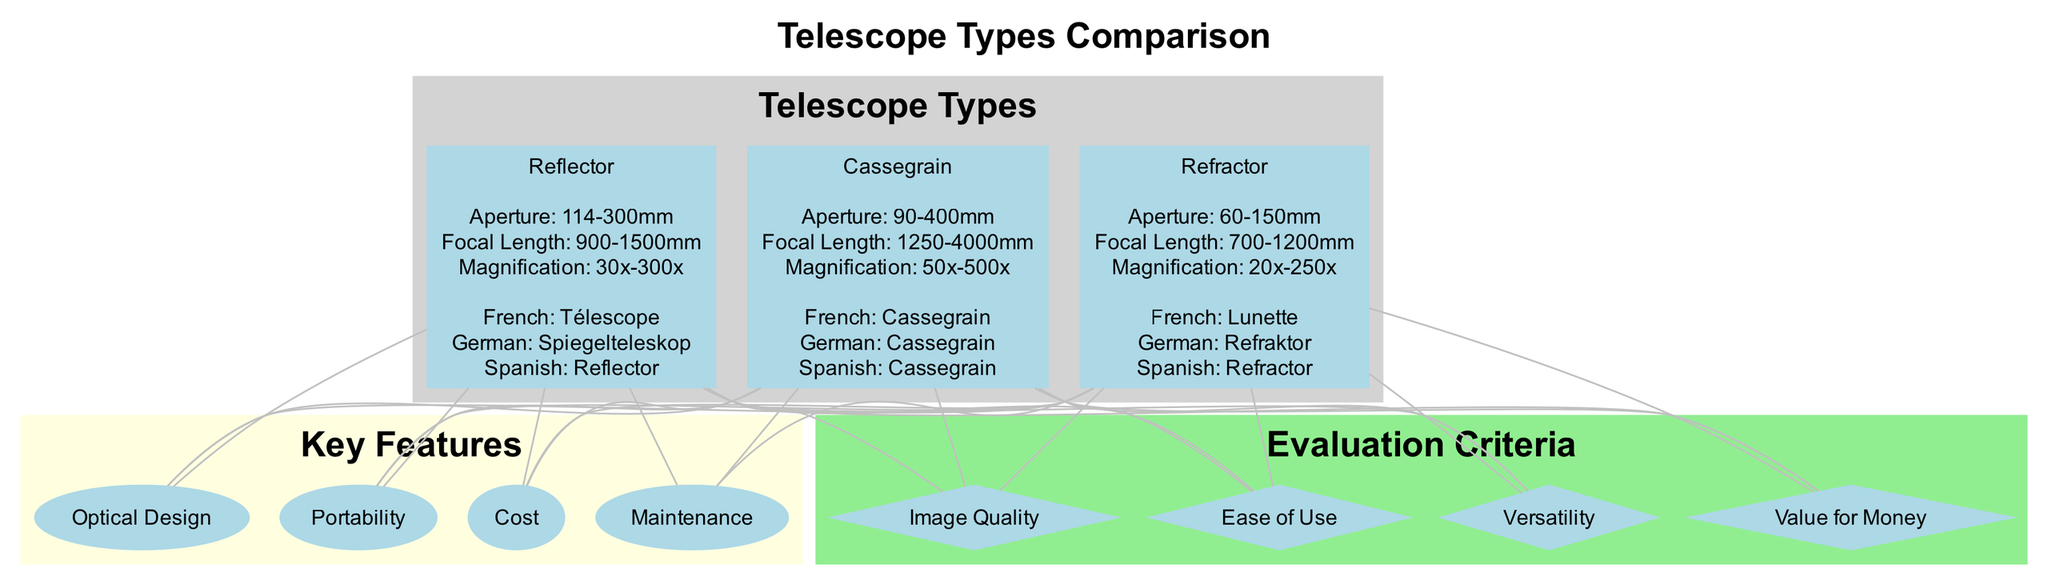What is the aperture range of the Refractor telescope? The "Refractor" telescope in the diagram lists the aperture range as "60-150mm". This information can be found in the specifications section corresponding to the "Refractor" node.
Answer: 60-150mm How many key features are listed in the diagram? The diagram includes a subgraph labeled "Key Features", which contains four features: "Optical Design," "Portability," "Cost," and "Maintenance." Counting these gives a total of four key features.
Answer: 4 What is the maximum magnification of the Cassegrain telescope? In the "Cassegrain" node, the specifications list the maximum magnification as "500x." This is the highest value indicated under the magnification specification for that particular telescope type.
Answer: 500x Which telescope type has the largest aperture range? Comparing the aperture ranges: "Refractor" (60-150mm), "Reflector" (114-300mm), and "Cassegrain" (90-400mm), the "Cassegrain" has the largest aperture range (90-400mm). Therefore, the reasoning involves evaluating the stated ranges to compare them accurately.
Answer: Cassegrain What is the localized term for Reflector in German? In the diagram, the "Reflector" telescope node provides a localized term for German as "Spiegelteleskop." This information is found under the localized terms section associated with the "Reflector" telescope.
Answer: Spiegelteleskop Which telescope type has the lowest minimum focal length? Evaluating the focal lengths: "Refractor" (700-1200mm), "Reflector" (900-1500mm), and "Cassegrain" (1250-4000mm), the "Refractor" has the lowest minimum focal length of 700mm noted in its specifications.
Answer: Refractor 